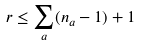<formula> <loc_0><loc_0><loc_500><loc_500>r \leq \sum _ { a } ( n _ { a } - 1 ) + 1</formula> 